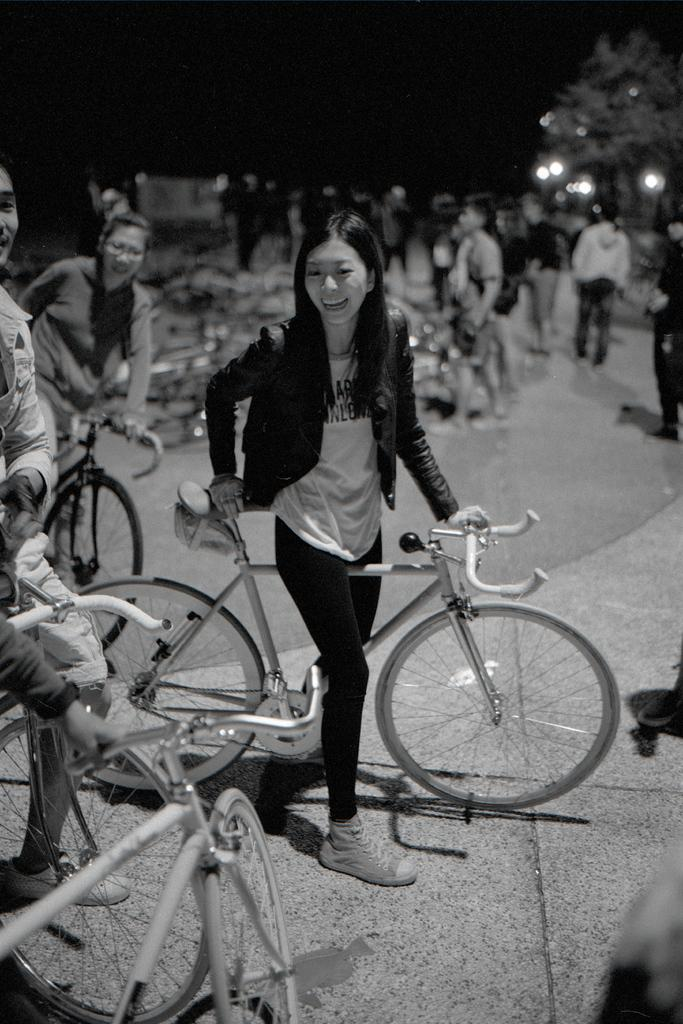What is happening in the image? There are people standing in the image. Can you describe a specific activity that some people are doing in the image? Yes, there are three people standing on bicycles in the image. What type of magic trick is being performed by the people in the image? There is no indication of a magic trick being performed in the image; it simply shows people standing on bicycles. Can you describe the car that is present in the image? There is no car present in the image; it only features people standing on bicycles. 